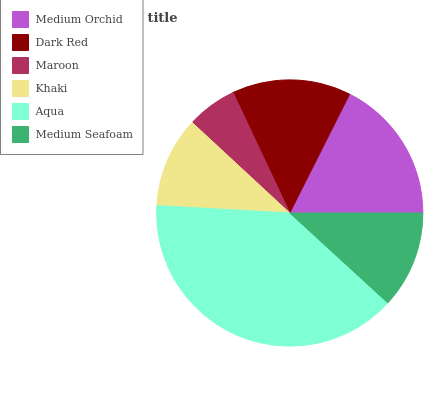Is Maroon the minimum?
Answer yes or no. Yes. Is Aqua the maximum?
Answer yes or no. Yes. Is Dark Red the minimum?
Answer yes or no. No. Is Dark Red the maximum?
Answer yes or no. No. Is Medium Orchid greater than Dark Red?
Answer yes or no. Yes. Is Dark Red less than Medium Orchid?
Answer yes or no. Yes. Is Dark Red greater than Medium Orchid?
Answer yes or no. No. Is Medium Orchid less than Dark Red?
Answer yes or no. No. Is Dark Red the high median?
Answer yes or no. Yes. Is Medium Seafoam the low median?
Answer yes or no. Yes. Is Maroon the high median?
Answer yes or no. No. Is Maroon the low median?
Answer yes or no. No. 